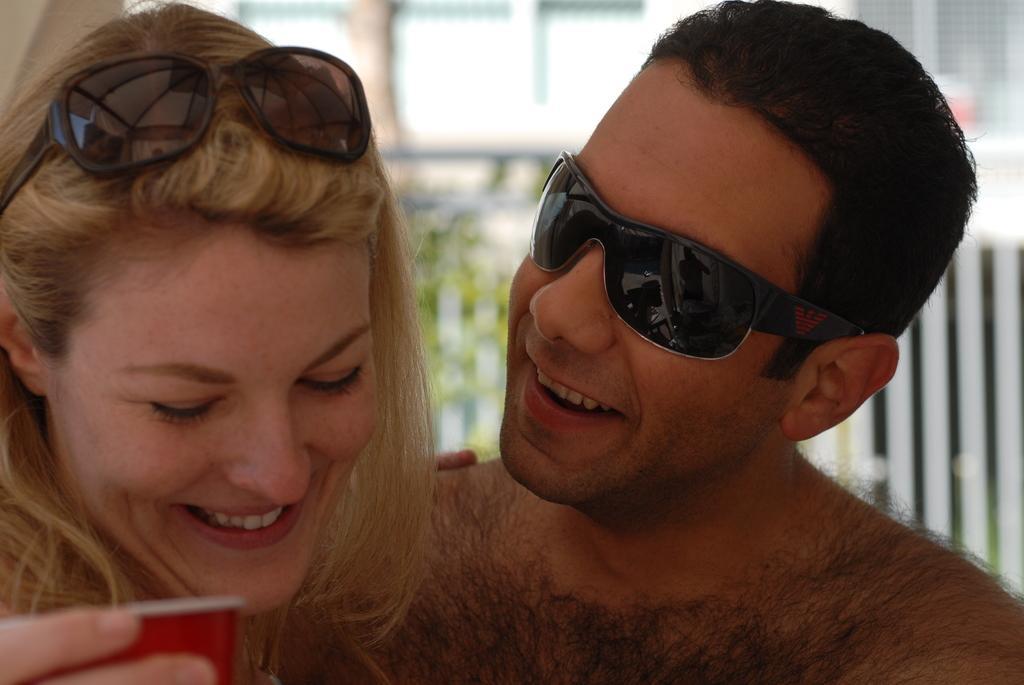Describe this image in one or two sentences. The picture consists of man and a woman. On the left the woman is holding a cup. On the right there is a man wearing spectacles. The background is blurred. In the background there are trees and buildings. Both are smiling. 